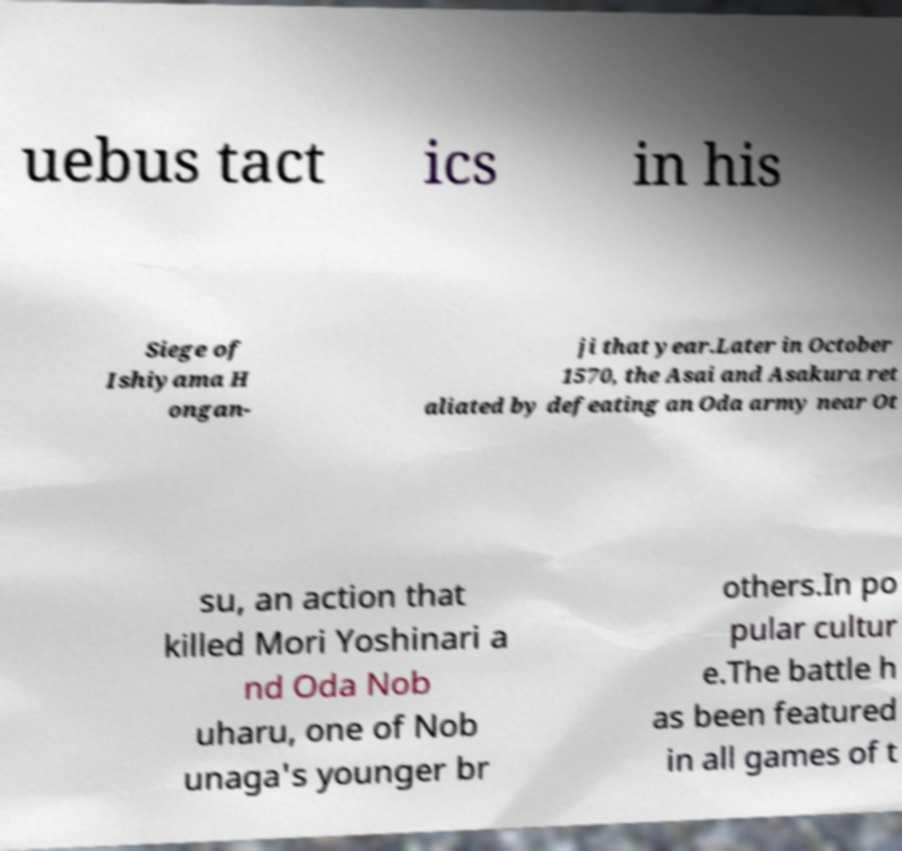Could you assist in decoding the text presented in this image and type it out clearly? uebus tact ics in his Siege of Ishiyama H ongan- ji that year.Later in October 1570, the Asai and Asakura ret aliated by defeating an Oda army near Ot su, an action that killed Mori Yoshinari a nd Oda Nob uharu, one of Nob unaga's younger br others.In po pular cultur e.The battle h as been featured in all games of t 